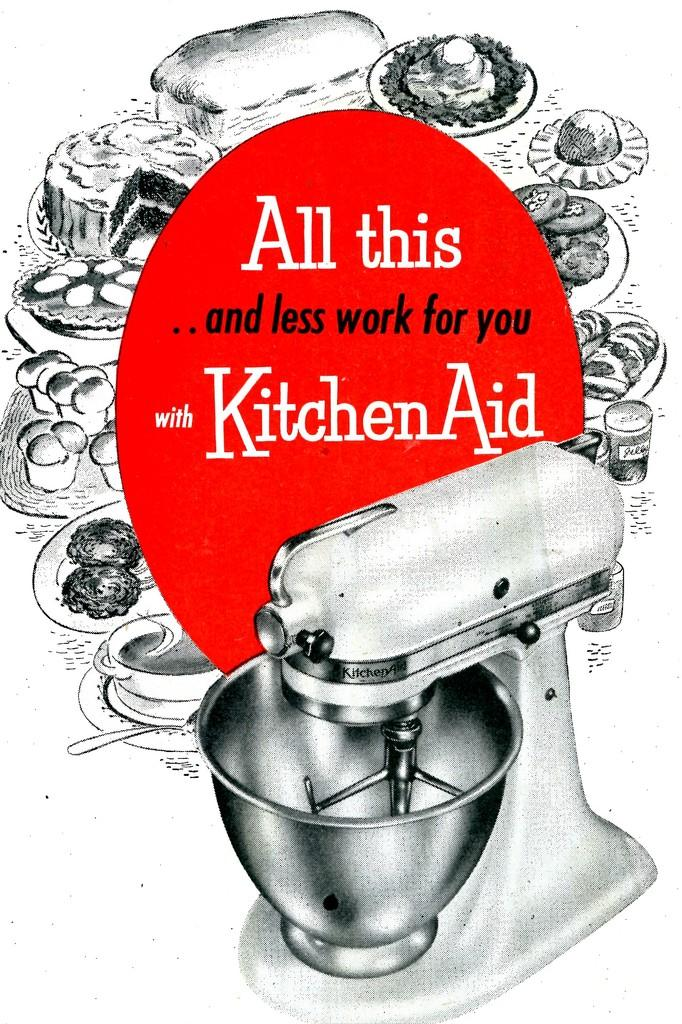<image>
Share a concise interpretation of the image provided. A poster adverd depicting a food mixer and various goodies, saying: "All this ..and less work for you with Kitchen Aid". 